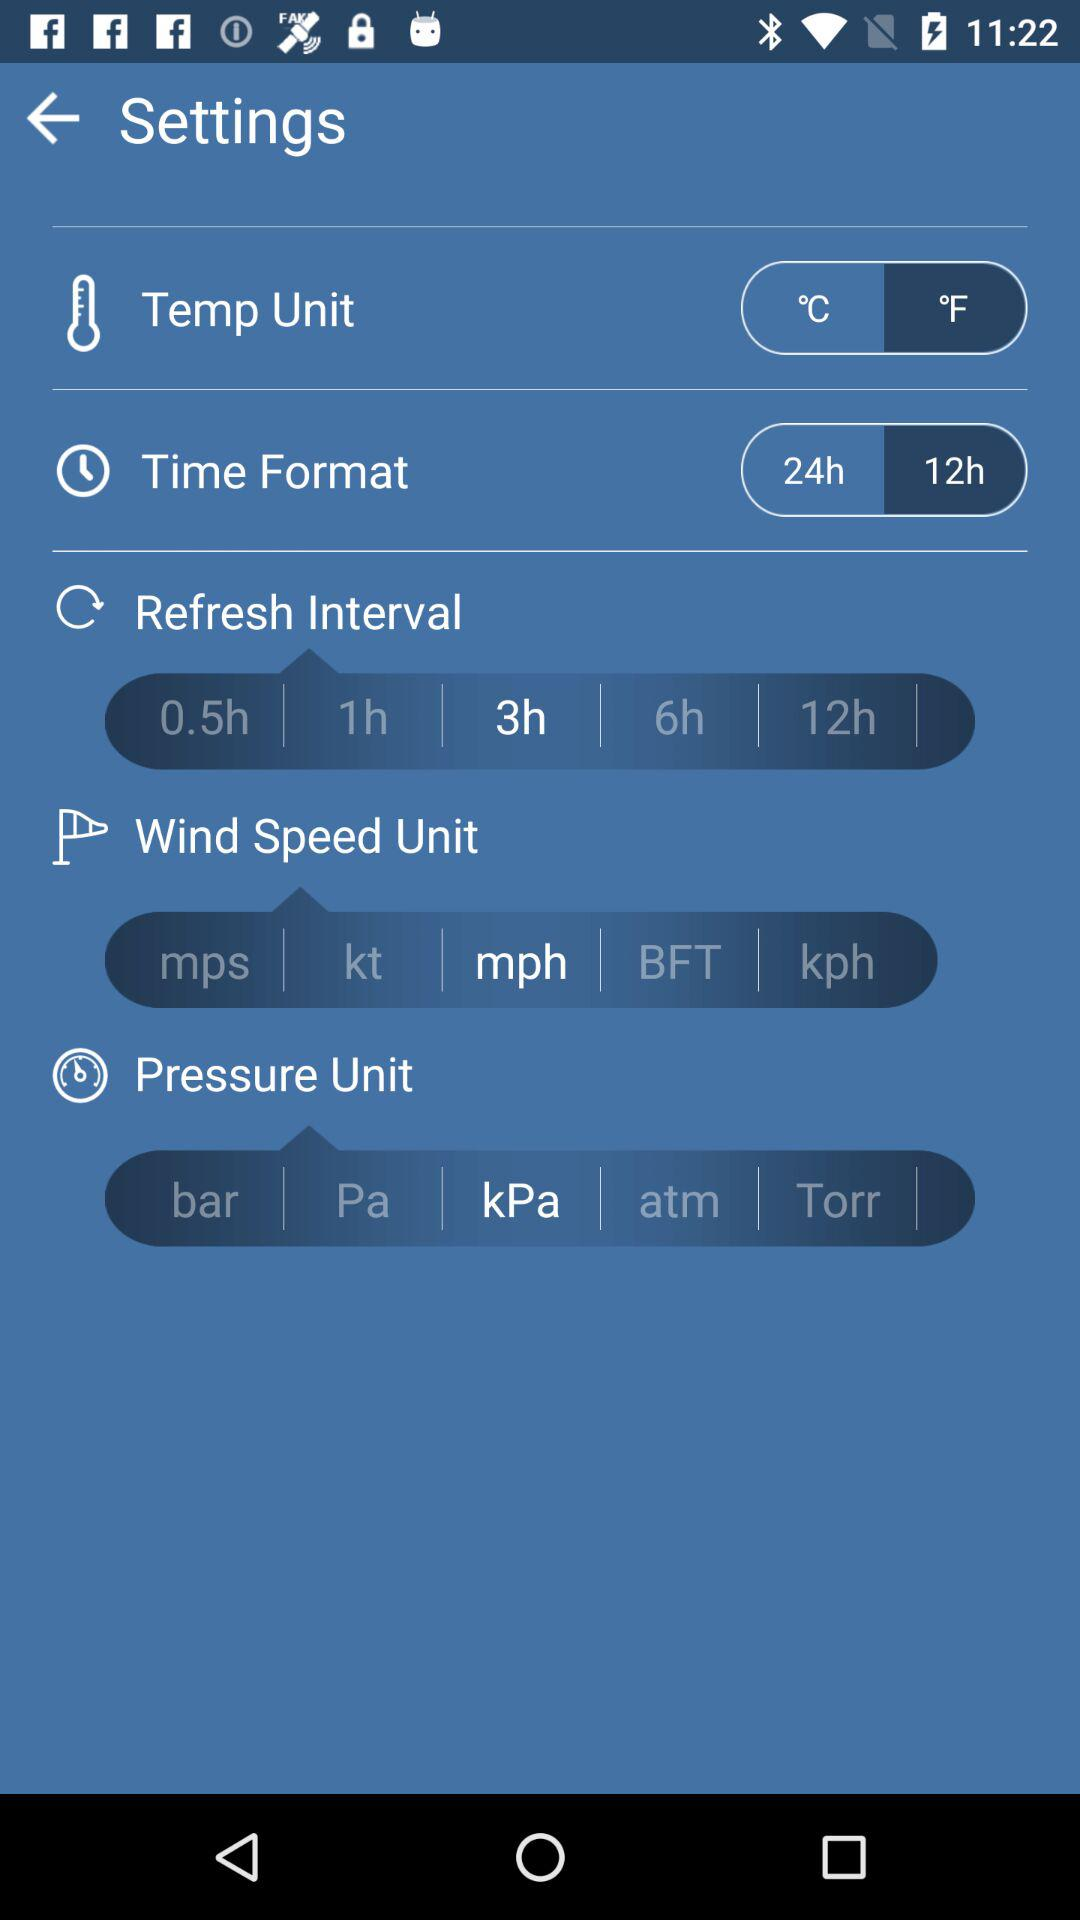What is the unit of temperature? The unit of temperature is °F. 